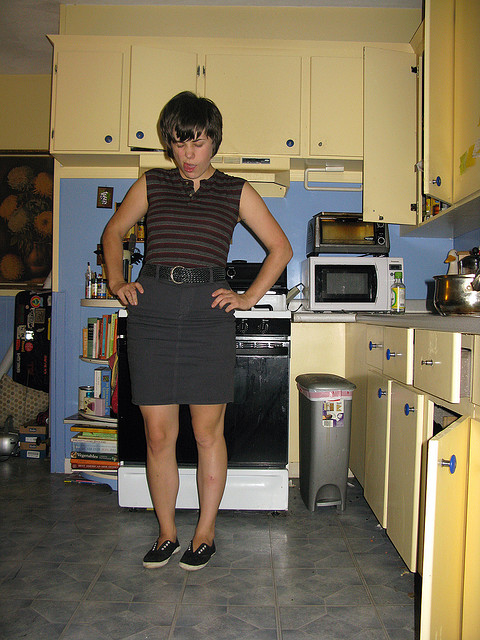How many ovens are there? 2 